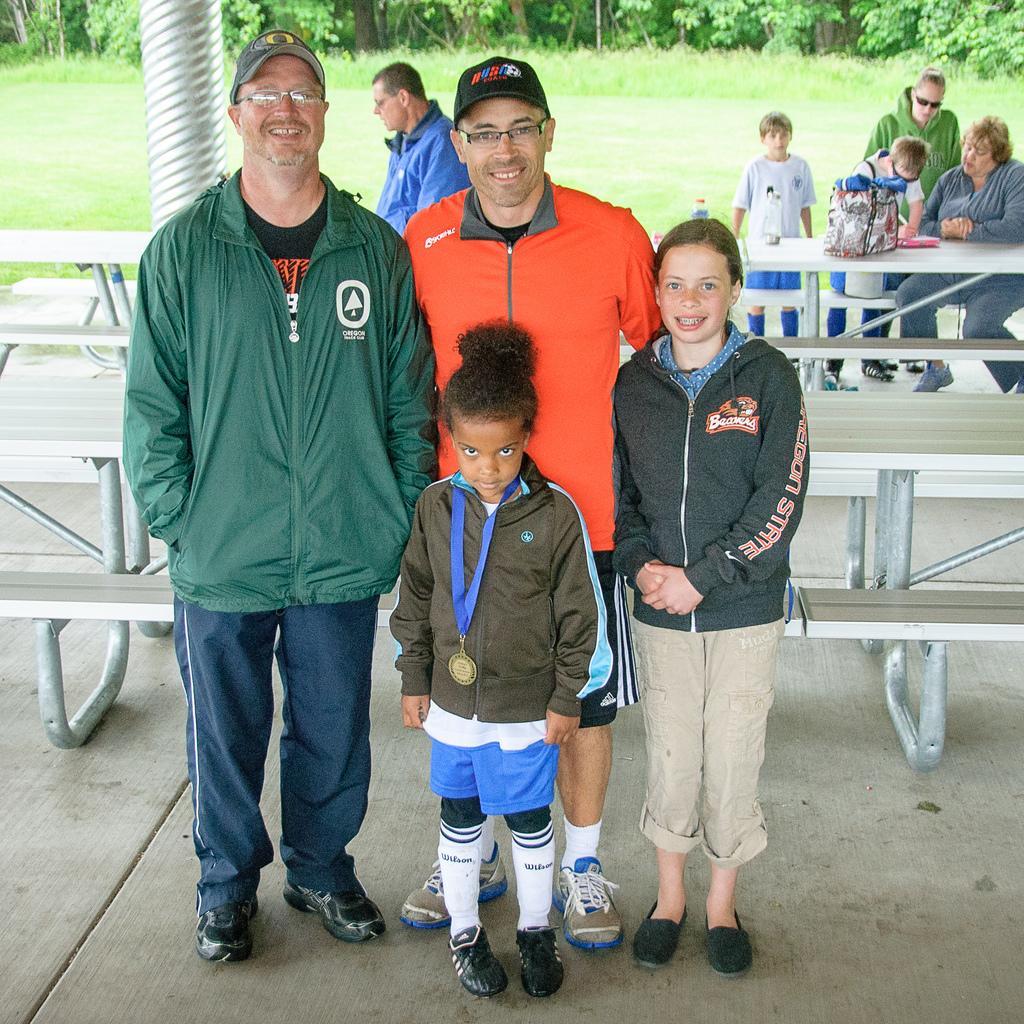Could you give a brief overview of what you see in this image? In this picture we can see four persons are standing in the front, there are benches in the middle, in the background we can see a woman is sitting and three persons are standing, we can also see some grass and trees in the background, there is another person in the middle. 